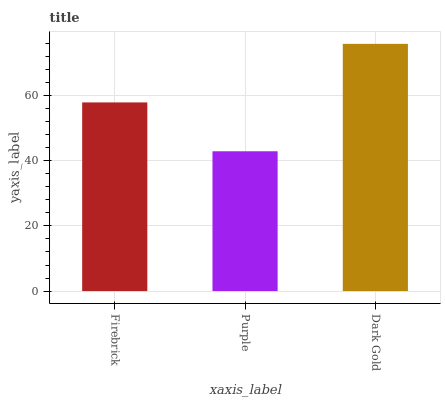Is Dark Gold the minimum?
Answer yes or no. No. Is Purple the maximum?
Answer yes or no. No. Is Dark Gold greater than Purple?
Answer yes or no. Yes. Is Purple less than Dark Gold?
Answer yes or no. Yes. Is Purple greater than Dark Gold?
Answer yes or no. No. Is Dark Gold less than Purple?
Answer yes or no. No. Is Firebrick the high median?
Answer yes or no. Yes. Is Firebrick the low median?
Answer yes or no. Yes. Is Dark Gold the high median?
Answer yes or no. No. Is Dark Gold the low median?
Answer yes or no. No. 